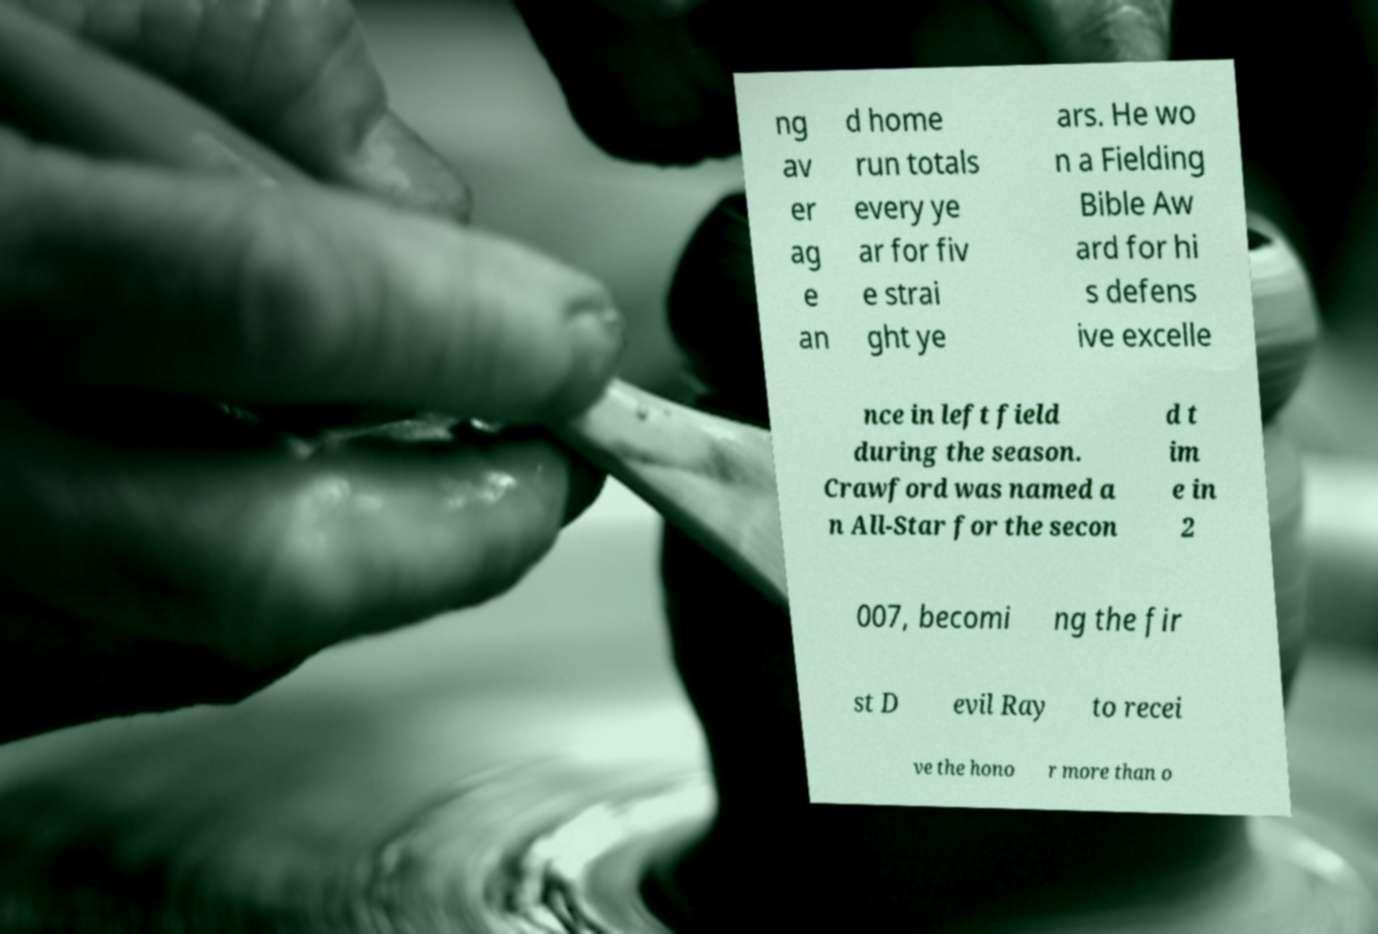What messages or text are displayed in this image? I need them in a readable, typed format. ng av er ag e an d home run totals every ye ar for fiv e strai ght ye ars. He wo n a Fielding Bible Aw ard for hi s defens ive excelle nce in left field during the season. Crawford was named a n All-Star for the secon d t im e in 2 007, becomi ng the fir st D evil Ray to recei ve the hono r more than o 